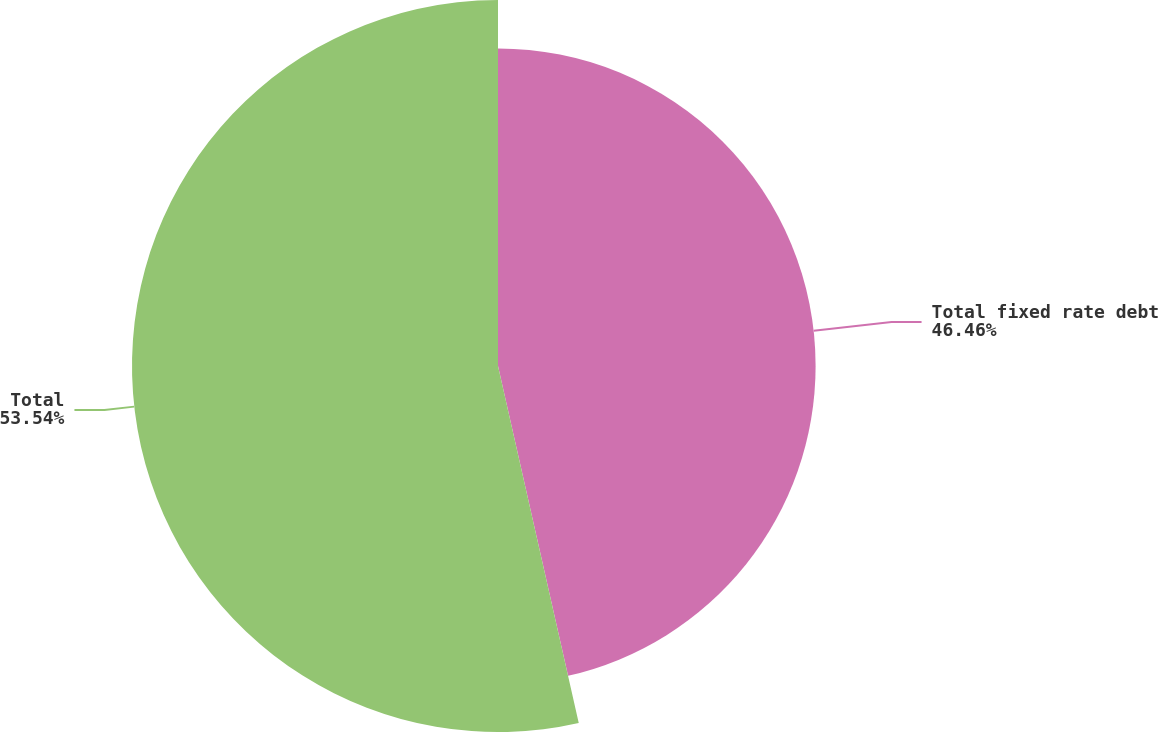Convert chart. <chart><loc_0><loc_0><loc_500><loc_500><pie_chart><fcel>Total fixed rate debt<fcel>Total<nl><fcel>46.46%<fcel>53.54%<nl></chart> 